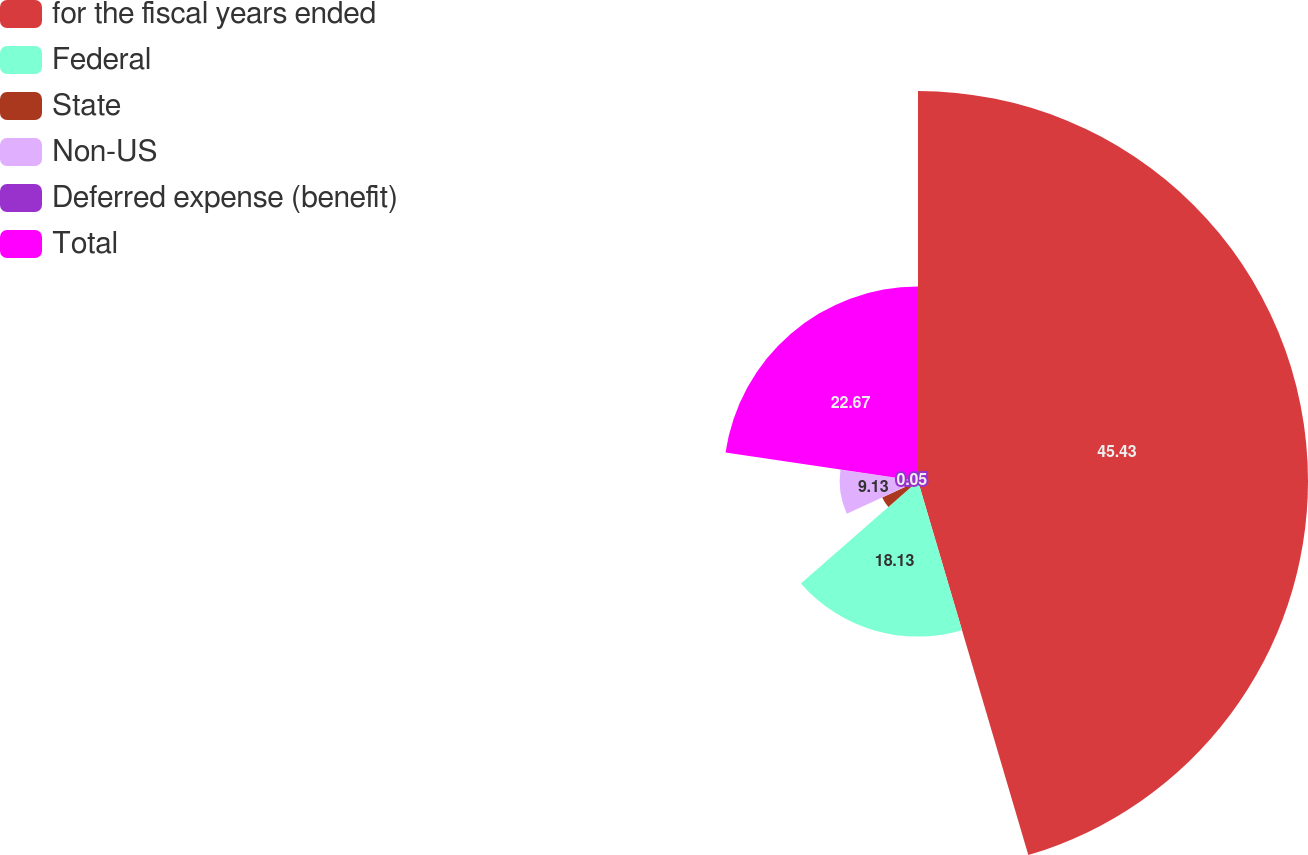Convert chart to OTSL. <chart><loc_0><loc_0><loc_500><loc_500><pie_chart><fcel>for the fiscal years ended<fcel>Federal<fcel>State<fcel>Non-US<fcel>Deferred expense (benefit)<fcel>Total<nl><fcel>45.44%<fcel>18.13%<fcel>4.59%<fcel>9.13%<fcel>0.05%<fcel>22.67%<nl></chart> 